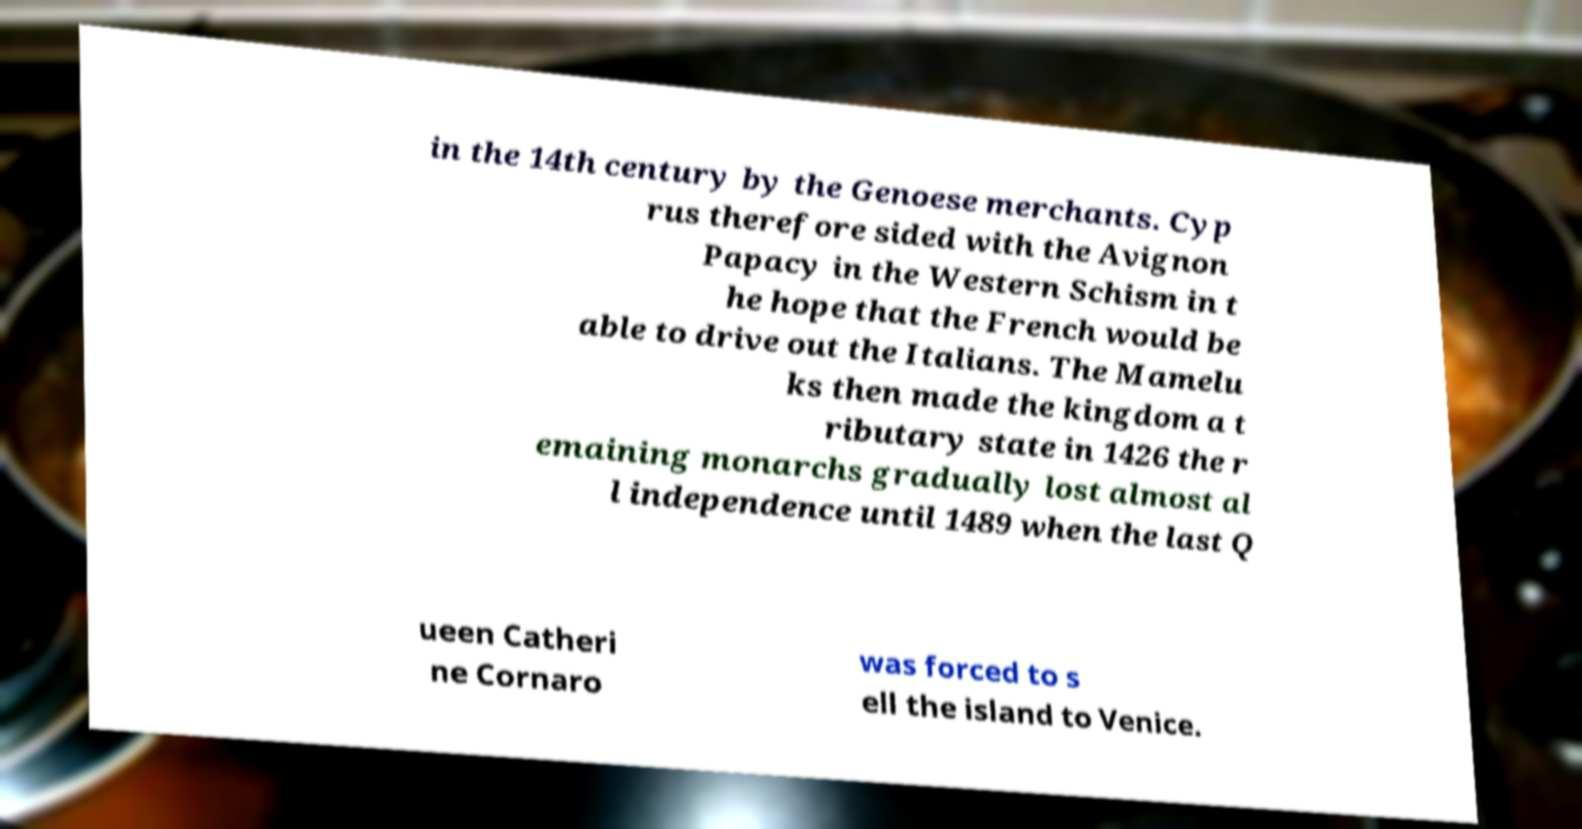What messages or text are displayed in this image? I need them in a readable, typed format. in the 14th century by the Genoese merchants. Cyp rus therefore sided with the Avignon Papacy in the Western Schism in t he hope that the French would be able to drive out the Italians. The Mamelu ks then made the kingdom a t ributary state in 1426 the r emaining monarchs gradually lost almost al l independence until 1489 when the last Q ueen Catheri ne Cornaro was forced to s ell the island to Venice. 